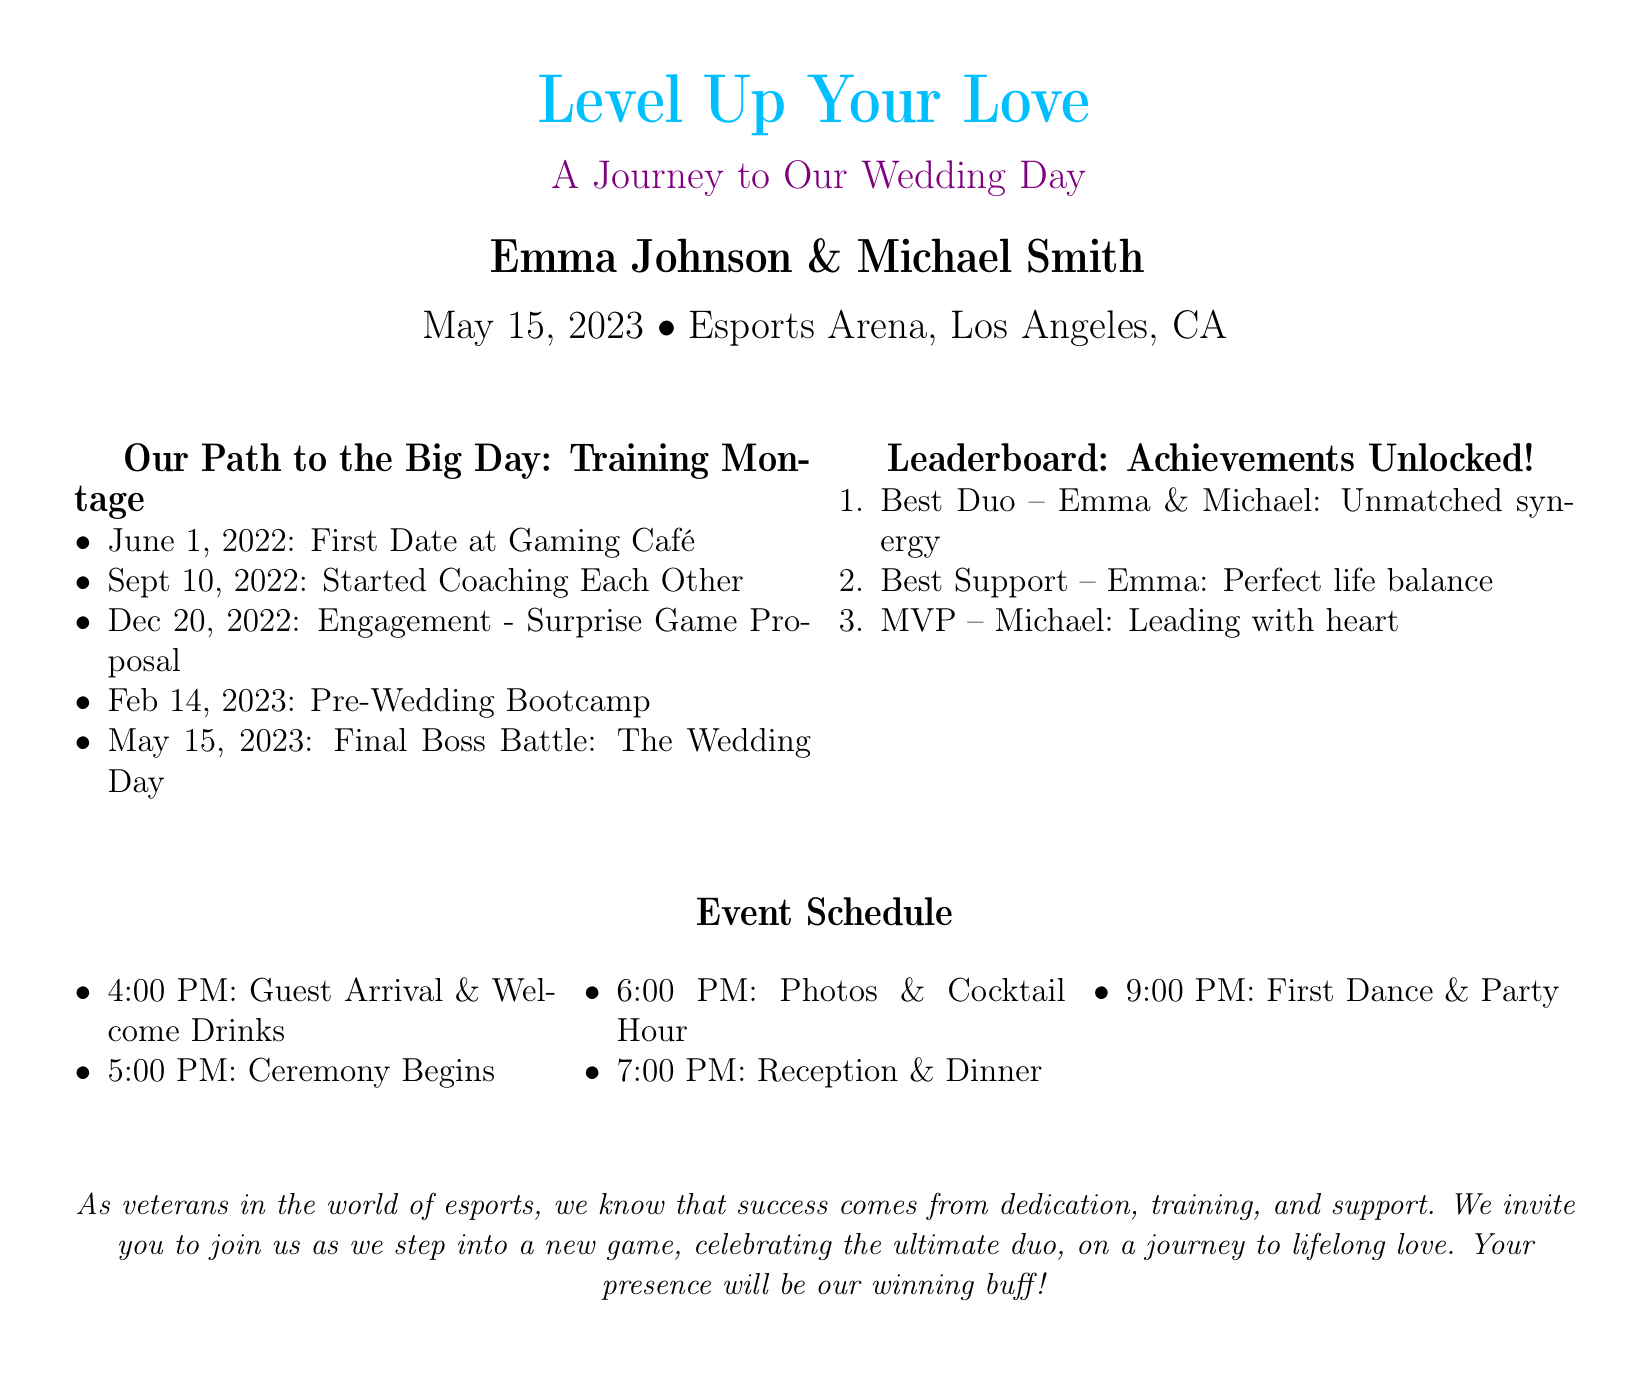what is the name of the couple getting married? The couple's names are explicitly stated at the top of the document.
Answer: Emma Johnson & Michael Smith when is the wedding date? The date is clearly mentioned in the central part of the document.
Answer: May 15, 2023 where is the wedding taking place? The location of the wedding is specified in the same section as the date.
Answer: Esports Arena, Los Angeles, CA how many milestones are listed in the Training Montage? The number of milestones can be counted from the list provided in the document.
Answer: 5 who is recognized as the MVP in the Leaderboard? The MVP award is specifically mentioned in the Leaderboard section.
Answer: Michael what event starts at 4:00 PM? The event time is given in the event schedule section.
Answer: Guest Arrival & Welcome Drinks what type of event is this document related to? The document is explicitly identified at the beginning as a wedding invitation.
Answer: Wedding what relationship milestone is highlighted on December 20, 2022? This milestone can be found in the Training Montage and indicates a significant event.
Answer: Engagement - Surprise Game Proposal what is referred to as the "Final Boss Battle"? This phrase is a unique term used to describe the wedding day in a gaming context.
Answer: The Wedding Day 